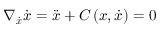<formula> <loc_0><loc_0><loc_500><loc_500>\nabla _ { \ D o t { \boldsymbol x } } \ D o t { x } = \ D d o t { \boldsymbol x } + C \left ( \boldsymbol x , \dot { \boldsymbol x } \right ) = 0</formula> 